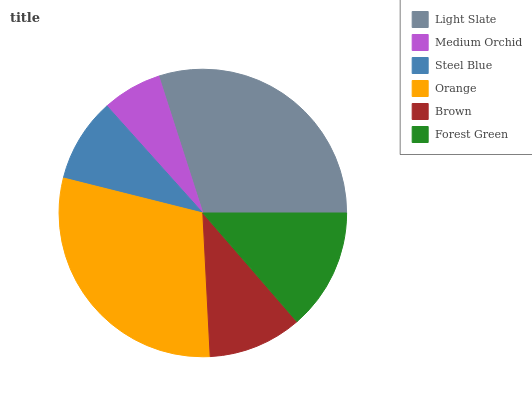Is Medium Orchid the minimum?
Answer yes or no. Yes. Is Light Slate the maximum?
Answer yes or no. Yes. Is Steel Blue the minimum?
Answer yes or no. No. Is Steel Blue the maximum?
Answer yes or no. No. Is Steel Blue greater than Medium Orchid?
Answer yes or no. Yes. Is Medium Orchid less than Steel Blue?
Answer yes or no. Yes. Is Medium Orchid greater than Steel Blue?
Answer yes or no. No. Is Steel Blue less than Medium Orchid?
Answer yes or no. No. Is Forest Green the high median?
Answer yes or no. Yes. Is Brown the low median?
Answer yes or no. Yes. Is Steel Blue the high median?
Answer yes or no. No. Is Orange the low median?
Answer yes or no. No. 